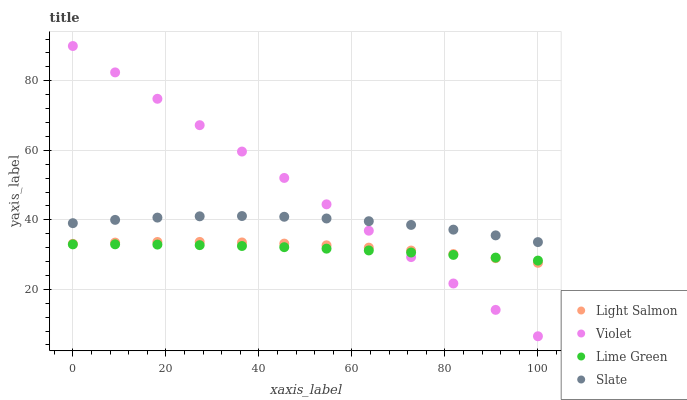Does Lime Green have the minimum area under the curve?
Answer yes or no. Yes. Does Violet have the maximum area under the curve?
Answer yes or no. Yes. Does Slate have the minimum area under the curve?
Answer yes or no. No. Does Slate have the maximum area under the curve?
Answer yes or no. No. Is Violet the smoothest?
Answer yes or no. Yes. Is Slate the roughest?
Answer yes or no. Yes. Is Lime Green the smoothest?
Answer yes or no. No. Is Lime Green the roughest?
Answer yes or no. No. Does Violet have the lowest value?
Answer yes or no. Yes. Does Lime Green have the lowest value?
Answer yes or no. No. Does Violet have the highest value?
Answer yes or no. Yes. Does Slate have the highest value?
Answer yes or no. No. Is Lime Green less than Slate?
Answer yes or no. Yes. Is Slate greater than Lime Green?
Answer yes or no. Yes. Does Slate intersect Violet?
Answer yes or no. Yes. Is Slate less than Violet?
Answer yes or no. No. Is Slate greater than Violet?
Answer yes or no. No. Does Lime Green intersect Slate?
Answer yes or no. No. 